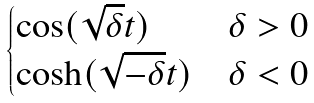Convert formula to latex. <formula><loc_0><loc_0><loc_500><loc_500>\begin{cases} \cos ( \sqrt { \delta } t ) & \delta > 0 \\ \cosh ( \sqrt { - \delta } t ) & \delta < 0 \end{cases}</formula> 